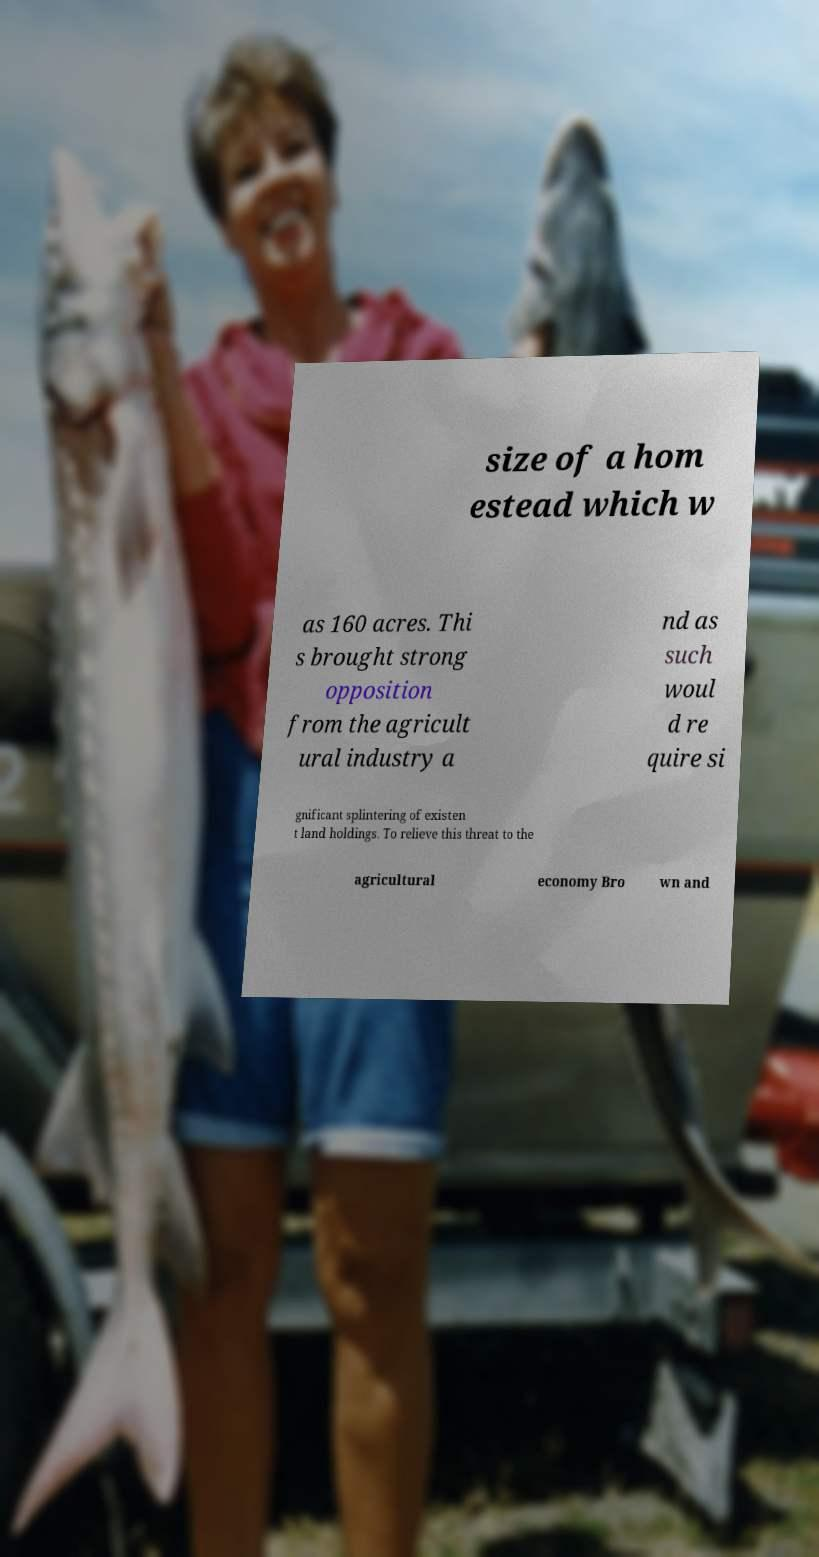For documentation purposes, I need the text within this image transcribed. Could you provide that? size of a hom estead which w as 160 acres. Thi s brought strong opposition from the agricult ural industry a nd as such woul d re quire si gnificant splintering of existen t land holdings. To relieve this threat to the agricultural economy Bro wn and 